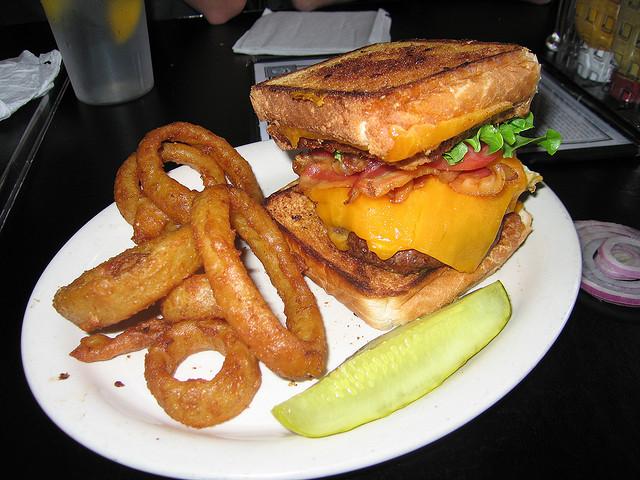How many onion rings are there?
Write a very short answer. 6. What kind of kind of meal is this?
Short answer required. Lunch. What has been removed and placed on the table?
Quick response, please. Onions. What type of bread is on this burger?
Answer briefly. Texas toast. 